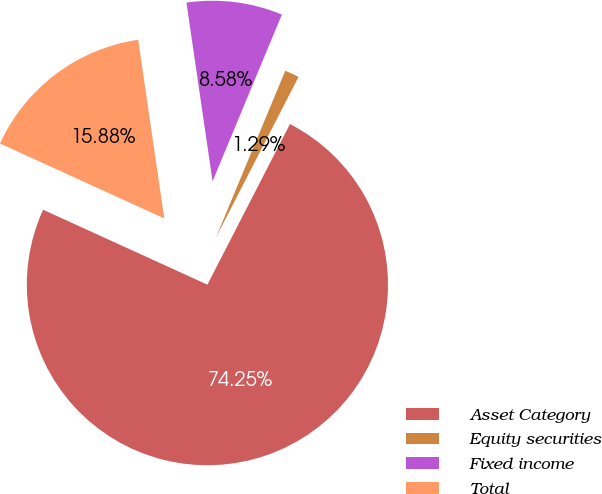<chart> <loc_0><loc_0><loc_500><loc_500><pie_chart><fcel>Asset Category<fcel>Equity securities<fcel>Fixed income<fcel>Total<nl><fcel>74.25%<fcel>1.29%<fcel>8.58%<fcel>15.88%<nl></chart> 